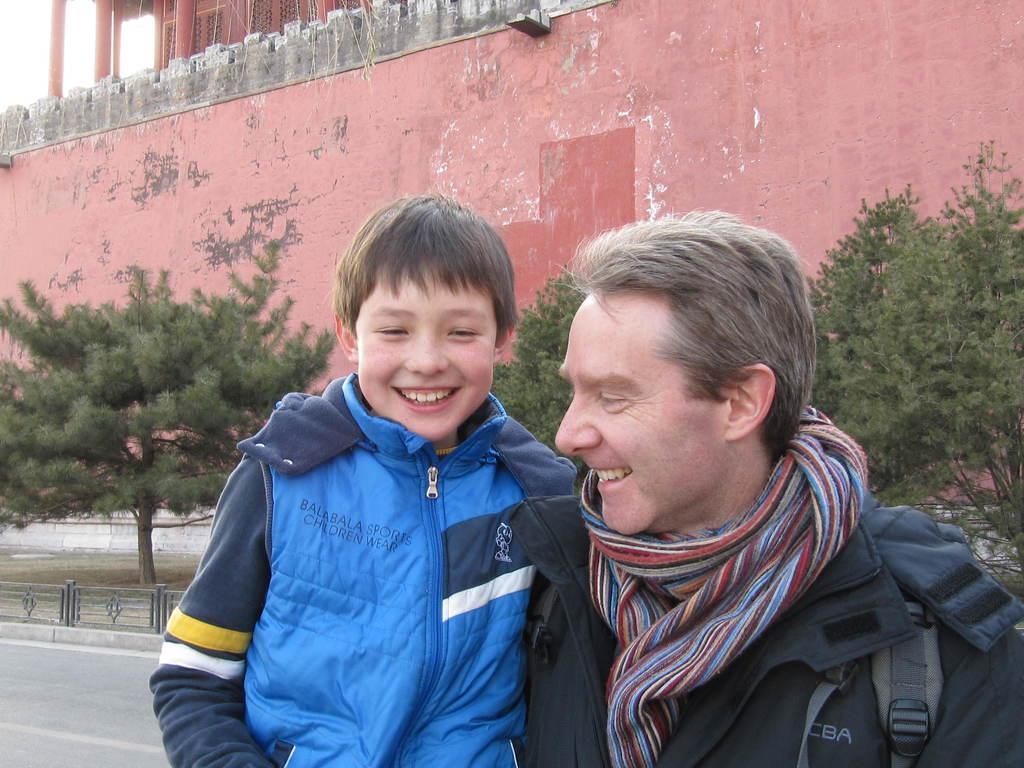How would you summarize this image in a sentence or two? In this image there is a man and a boy smiling , and in the background there are iron grills, road, building, trees, sky. 